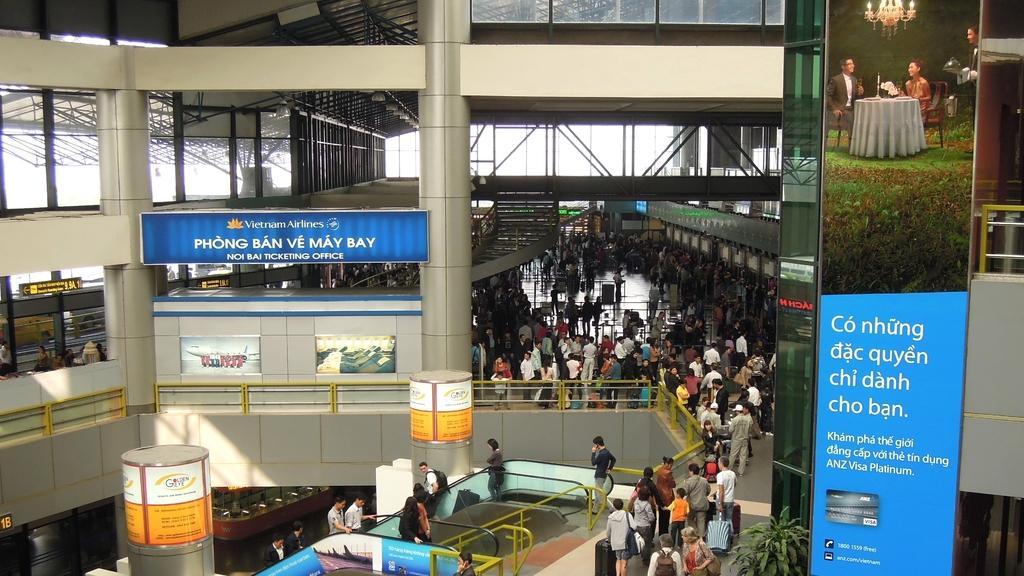In one or two sentences, can you explain what this image depicts? In this image, there are a few people. We can see the ground with some objects. We can see some boards with text and images. We can also see some pillars and the fence. We can see some metal objects. 